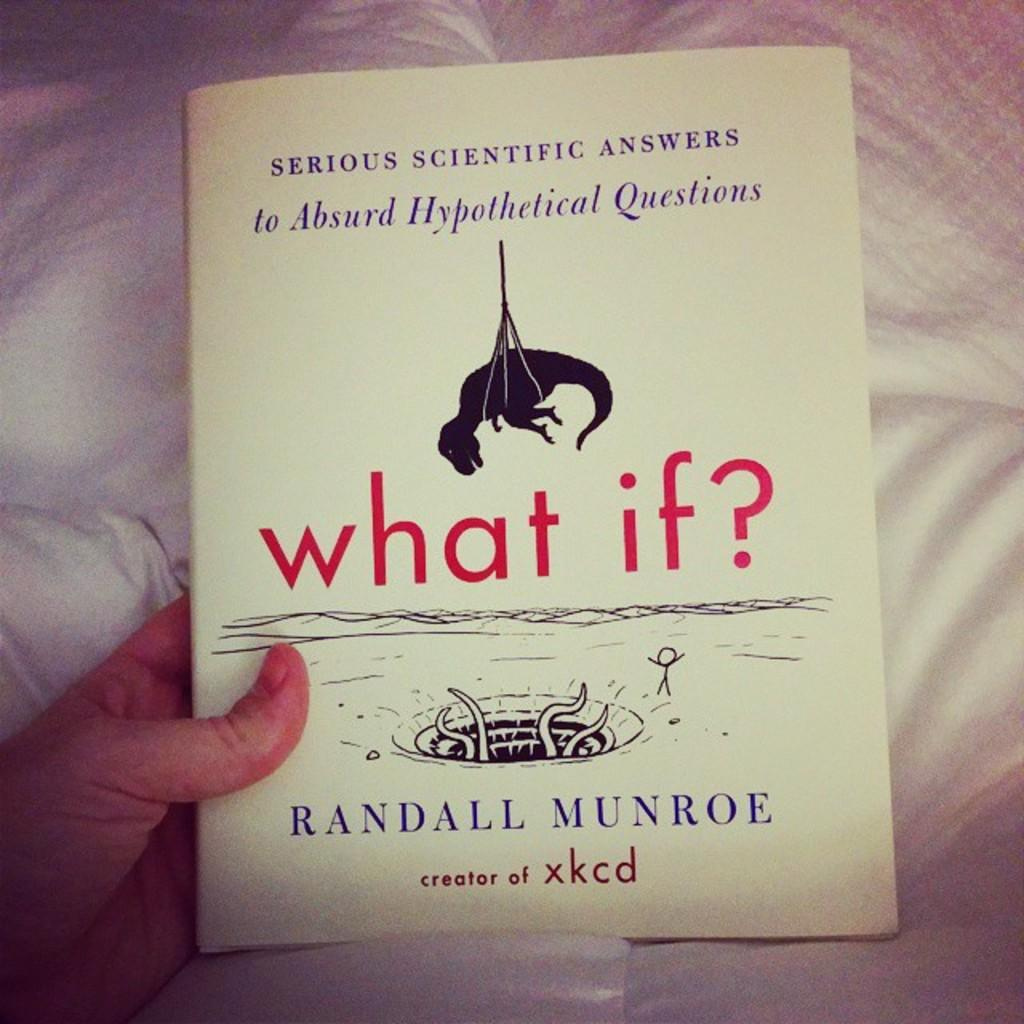<image>
Create a compact narrative representing the image presented. Someone is holding a book by Randall Munroe and is called what if. 